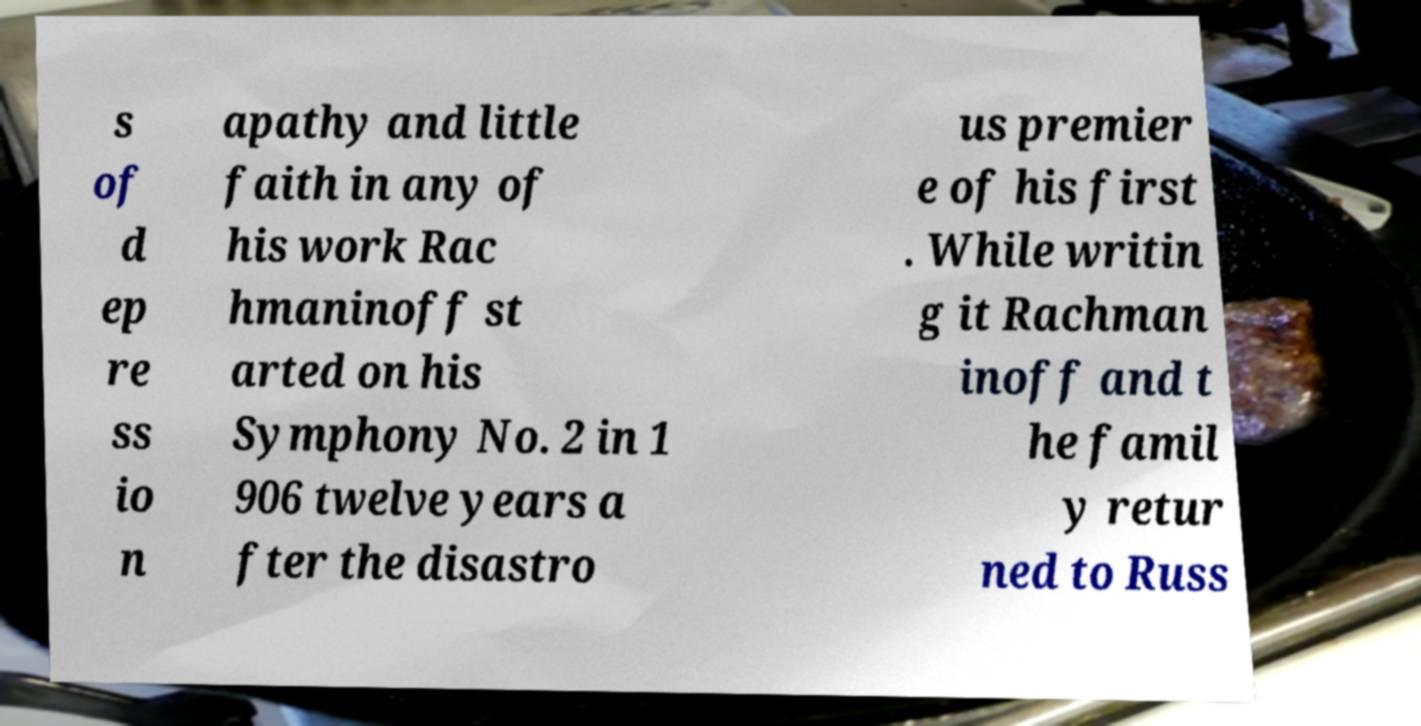I need the written content from this picture converted into text. Can you do that? s of d ep re ss io n apathy and little faith in any of his work Rac hmaninoff st arted on his Symphony No. 2 in 1 906 twelve years a fter the disastro us premier e of his first . While writin g it Rachman inoff and t he famil y retur ned to Russ 